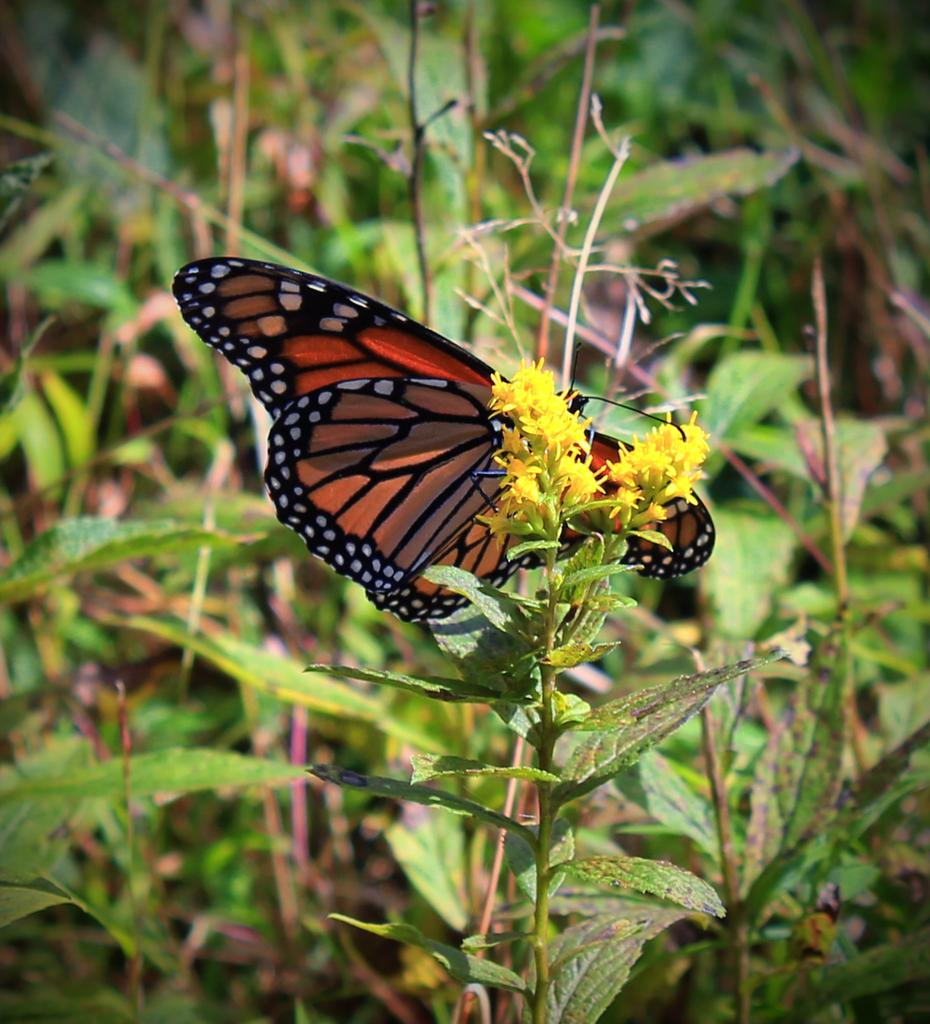What is the main subject of the image? There is a butterfly in the image. Where is the butterfly located? The butterfly is on a flower. What can be seen in the background of the image? There are plants visible in the background of the image. What alley or way does the butterfly twist and turn in the image? There is no alley or way present in the image, and the butterfly is not shown twisting or turning. 